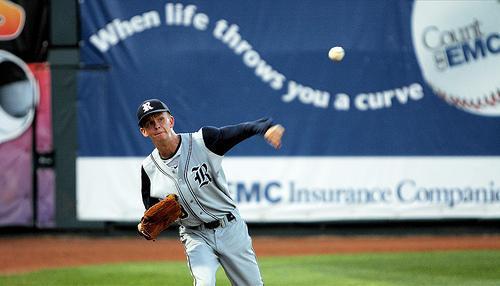How many balls are shown?
Give a very brief answer. 1. 